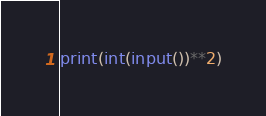<code> <loc_0><loc_0><loc_500><loc_500><_Python_>print(int(input())**2)
</code> 